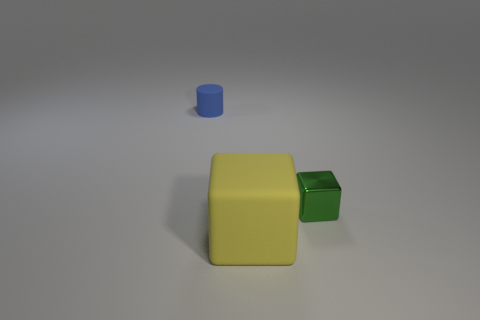Are there any other things that have the same size as the yellow matte block?
Offer a very short reply. No. How many objects are behind the yellow rubber block and in front of the blue rubber object?
Make the answer very short. 1. What material is the tiny object that is behind the tiny object that is to the right of the object that is behind the small green thing made of?
Ensure brevity in your answer.  Rubber. How many big yellow things have the same material as the blue thing?
Give a very brief answer. 1. The other object that is the same size as the metal object is what shape?
Ensure brevity in your answer.  Cylinder. Are there any large yellow blocks on the left side of the tiny blue cylinder?
Keep it short and to the point. No. Are there any other tiny rubber things of the same shape as the tiny matte object?
Offer a terse response. No. Is the shape of the matte thing right of the blue matte cylinder the same as the tiny thing to the right of the tiny blue rubber cylinder?
Provide a short and direct response. Yes. Are there any cyan blocks that have the same size as the blue cylinder?
Provide a short and direct response. No. Are there an equal number of blue cylinders that are in front of the yellow matte block and yellow things that are to the right of the small cylinder?
Offer a terse response. No. 